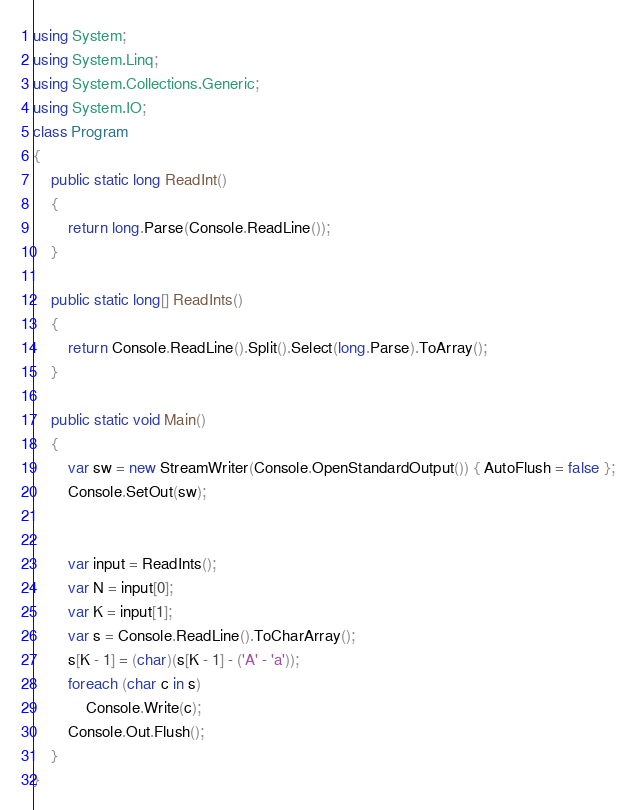Convert code to text. <code><loc_0><loc_0><loc_500><loc_500><_C#_>using System;
using System.Linq;
using System.Collections.Generic;
using System.IO;
class Program
{
    public static long ReadInt()
    {
        return long.Parse(Console.ReadLine());
    }

    public static long[] ReadInts()
    {
        return Console.ReadLine().Split().Select(long.Parse).ToArray();
    }

    public static void Main()
    {
        var sw = new StreamWriter(Console.OpenStandardOutput()) { AutoFlush = false };
        Console.SetOut(sw);
       
     
        var input = ReadInts();
        var N = input[0];
        var K = input[1];
        var s = Console.ReadLine().ToCharArray();
        s[K - 1] = (char)(s[K - 1] - ('A' - 'a'));
        foreach (char c in s)
            Console.Write(c);
        Console.Out.Flush();
    }
}</code> 